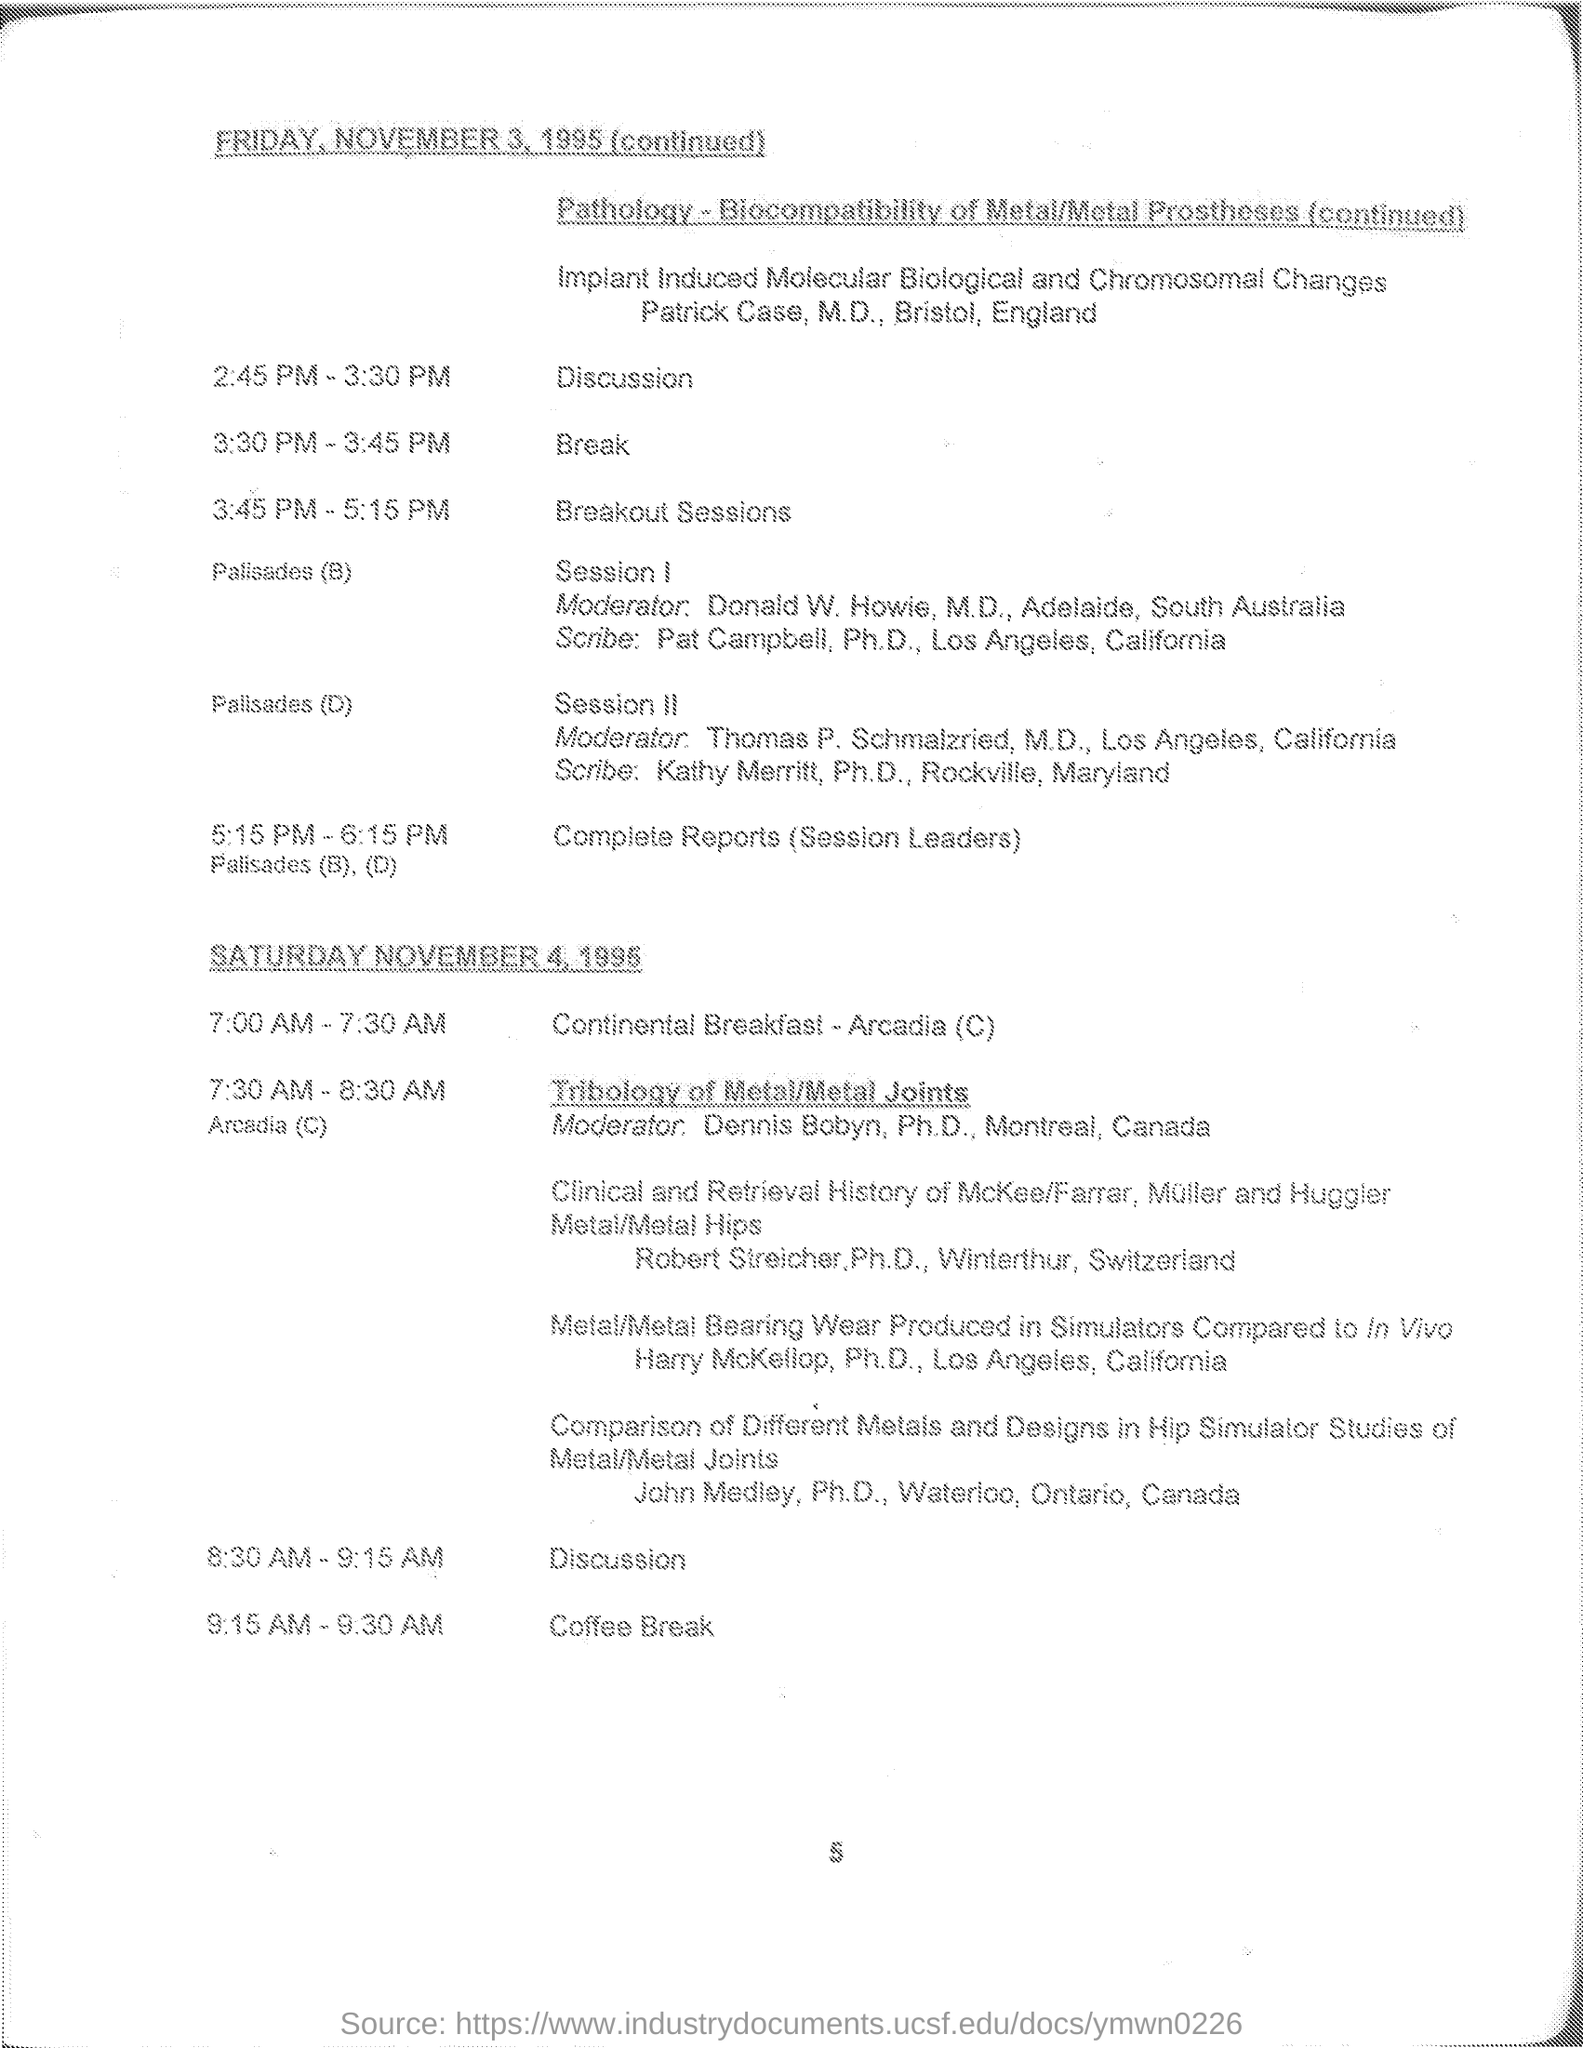List a handful of essential elements in this visual. The break during the November 3rd program will occur from 3:30 PM to 3:45 PM. The breakout sessions will take place on November 3rd from 3:45 PM to 5:15 PM. The coffee break is scheduled to occur between 9:15 AM and 9:30 AM. The complete Reports (session leaders) session is scheduled for November 3, from 5:15 PM to 6:15 PM. The continental breakfast will take place from 7:00 AM to 7:30 AM. 